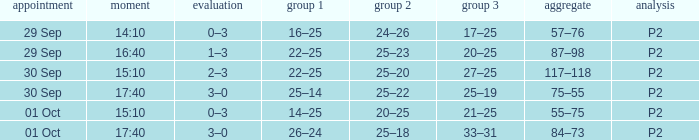What Score has a time of 14:10? 0–3. 